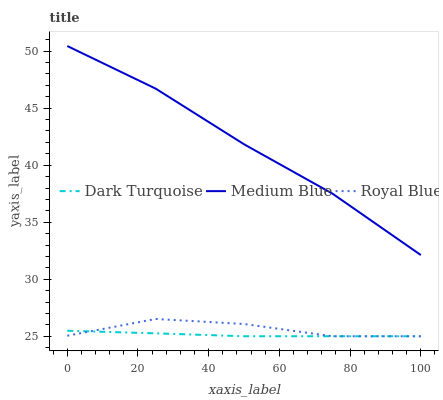Does Royal Blue have the minimum area under the curve?
Answer yes or no. No. Does Royal Blue have the maximum area under the curve?
Answer yes or no. No. Is Medium Blue the smoothest?
Answer yes or no. No. Is Medium Blue the roughest?
Answer yes or no. No. Does Medium Blue have the lowest value?
Answer yes or no. No. Does Royal Blue have the highest value?
Answer yes or no. No. Is Royal Blue less than Medium Blue?
Answer yes or no. Yes. Is Medium Blue greater than Royal Blue?
Answer yes or no. Yes. Does Royal Blue intersect Medium Blue?
Answer yes or no. No. 